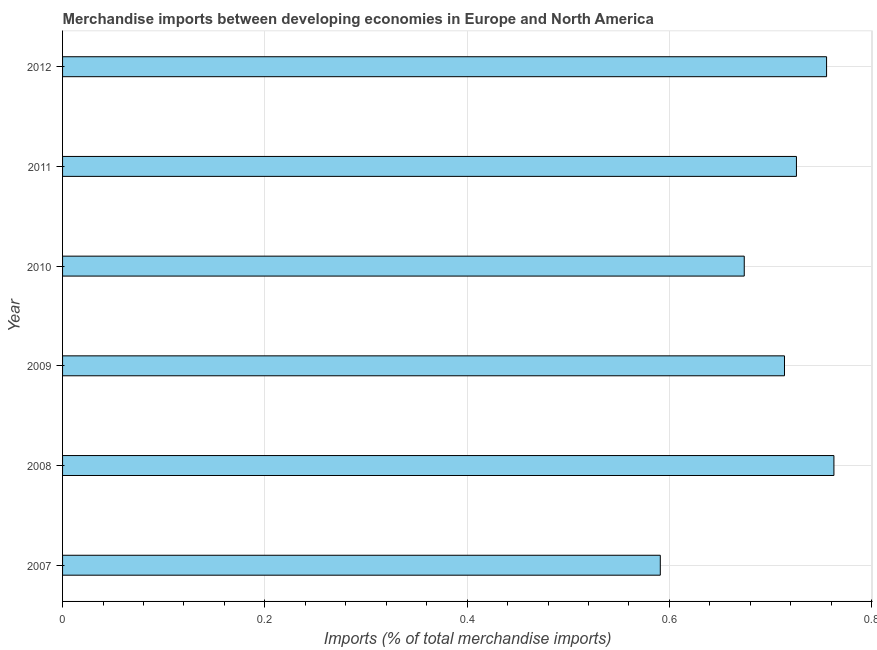What is the title of the graph?
Provide a succinct answer. Merchandise imports between developing economies in Europe and North America. What is the label or title of the X-axis?
Make the answer very short. Imports (% of total merchandise imports). What is the merchandise imports in 2009?
Offer a terse response. 0.71. Across all years, what is the maximum merchandise imports?
Offer a terse response. 0.76. Across all years, what is the minimum merchandise imports?
Make the answer very short. 0.59. In which year was the merchandise imports maximum?
Your answer should be very brief. 2008. What is the sum of the merchandise imports?
Offer a very short reply. 4.22. What is the average merchandise imports per year?
Offer a very short reply. 0.7. What is the median merchandise imports?
Give a very brief answer. 0.72. In how many years, is the merchandise imports greater than 0.48 %?
Keep it short and to the point. 6. What is the ratio of the merchandise imports in 2010 to that in 2011?
Ensure brevity in your answer.  0.93. Is the merchandise imports in 2009 less than that in 2010?
Your response must be concise. No. What is the difference between the highest and the second highest merchandise imports?
Your answer should be compact. 0.01. Is the sum of the merchandise imports in 2009 and 2010 greater than the maximum merchandise imports across all years?
Ensure brevity in your answer.  Yes. What is the difference between the highest and the lowest merchandise imports?
Provide a succinct answer. 0.17. Are all the bars in the graph horizontal?
Your answer should be very brief. Yes. How many years are there in the graph?
Your response must be concise. 6. Are the values on the major ticks of X-axis written in scientific E-notation?
Offer a very short reply. No. What is the Imports (% of total merchandise imports) of 2007?
Your answer should be compact. 0.59. What is the Imports (% of total merchandise imports) of 2008?
Make the answer very short. 0.76. What is the Imports (% of total merchandise imports) in 2009?
Your answer should be compact. 0.71. What is the Imports (% of total merchandise imports) in 2010?
Offer a terse response. 0.67. What is the Imports (% of total merchandise imports) in 2011?
Give a very brief answer. 0.73. What is the Imports (% of total merchandise imports) in 2012?
Offer a terse response. 0.76. What is the difference between the Imports (% of total merchandise imports) in 2007 and 2008?
Give a very brief answer. -0.17. What is the difference between the Imports (% of total merchandise imports) in 2007 and 2009?
Provide a short and direct response. -0.12. What is the difference between the Imports (% of total merchandise imports) in 2007 and 2010?
Offer a terse response. -0.08. What is the difference between the Imports (% of total merchandise imports) in 2007 and 2011?
Ensure brevity in your answer.  -0.13. What is the difference between the Imports (% of total merchandise imports) in 2007 and 2012?
Ensure brevity in your answer.  -0.16. What is the difference between the Imports (% of total merchandise imports) in 2008 and 2009?
Your answer should be compact. 0.05. What is the difference between the Imports (% of total merchandise imports) in 2008 and 2010?
Your answer should be very brief. 0.09. What is the difference between the Imports (% of total merchandise imports) in 2008 and 2011?
Provide a succinct answer. 0.04. What is the difference between the Imports (% of total merchandise imports) in 2008 and 2012?
Provide a short and direct response. 0.01. What is the difference between the Imports (% of total merchandise imports) in 2009 and 2010?
Offer a very short reply. 0.04. What is the difference between the Imports (% of total merchandise imports) in 2009 and 2011?
Offer a terse response. -0.01. What is the difference between the Imports (% of total merchandise imports) in 2009 and 2012?
Offer a terse response. -0.04. What is the difference between the Imports (% of total merchandise imports) in 2010 and 2011?
Ensure brevity in your answer.  -0.05. What is the difference between the Imports (% of total merchandise imports) in 2010 and 2012?
Offer a terse response. -0.08. What is the difference between the Imports (% of total merchandise imports) in 2011 and 2012?
Your answer should be very brief. -0.03. What is the ratio of the Imports (% of total merchandise imports) in 2007 to that in 2008?
Give a very brief answer. 0.78. What is the ratio of the Imports (% of total merchandise imports) in 2007 to that in 2009?
Ensure brevity in your answer.  0.83. What is the ratio of the Imports (% of total merchandise imports) in 2007 to that in 2010?
Give a very brief answer. 0.88. What is the ratio of the Imports (% of total merchandise imports) in 2007 to that in 2011?
Ensure brevity in your answer.  0.81. What is the ratio of the Imports (% of total merchandise imports) in 2007 to that in 2012?
Make the answer very short. 0.78. What is the ratio of the Imports (% of total merchandise imports) in 2008 to that in 2009?
Provide a succinct answer. 1.07. What is the ratio of the Imports (% of total merchandise imports) in 2008 to that in 2010?
Ensure brevity in your answer.  1.13. What is the ratio of the Imports (% of total merchandise imports) in 2008 to that in 2011?
Provide a succinct answer. 1.05. What is the ratio of the Imports (% of total merchandise imports) in 2009 to that in 2010?
Provide a short and direct response. 1.06. What is the ratio of the Imports (% of total merchandise imports) in 2009 to that in 2012?
Provide a short and direct response. 0.94. What is the ratio of the Imports (% of total merchandise imports) in 2010 to that in 2011?
Offer a terse response. 0.93. What is the ratio of the Imports (% of total merchandise imports) in 2010 to that in 2012?
Your response must be concise. 0.89. 